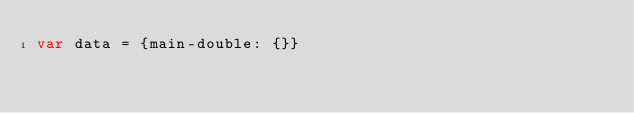Convert code to text. <code><loc_0><loc_0><loc_500><loc_500><_JavaScript_>var data = {main-double: {}}</code> 